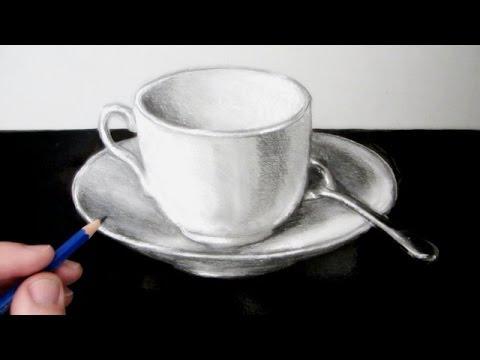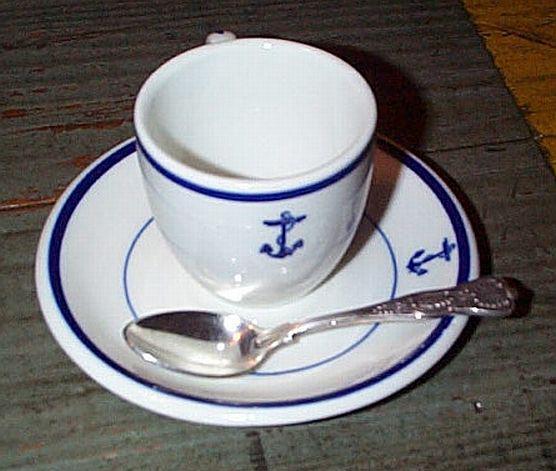The first image is the image on the left, the second image is the image on the right. Considering the images on both sides, is "Both cups have a spoon sitting on their saucer." valid? Answer yes or no. Yes. The first image is the image on the left, the second image is the image on the right. For the images shown, is this caption "In each image there is a spoon laid next to the cup on the plate." true? Answer yes or no. Yes. 